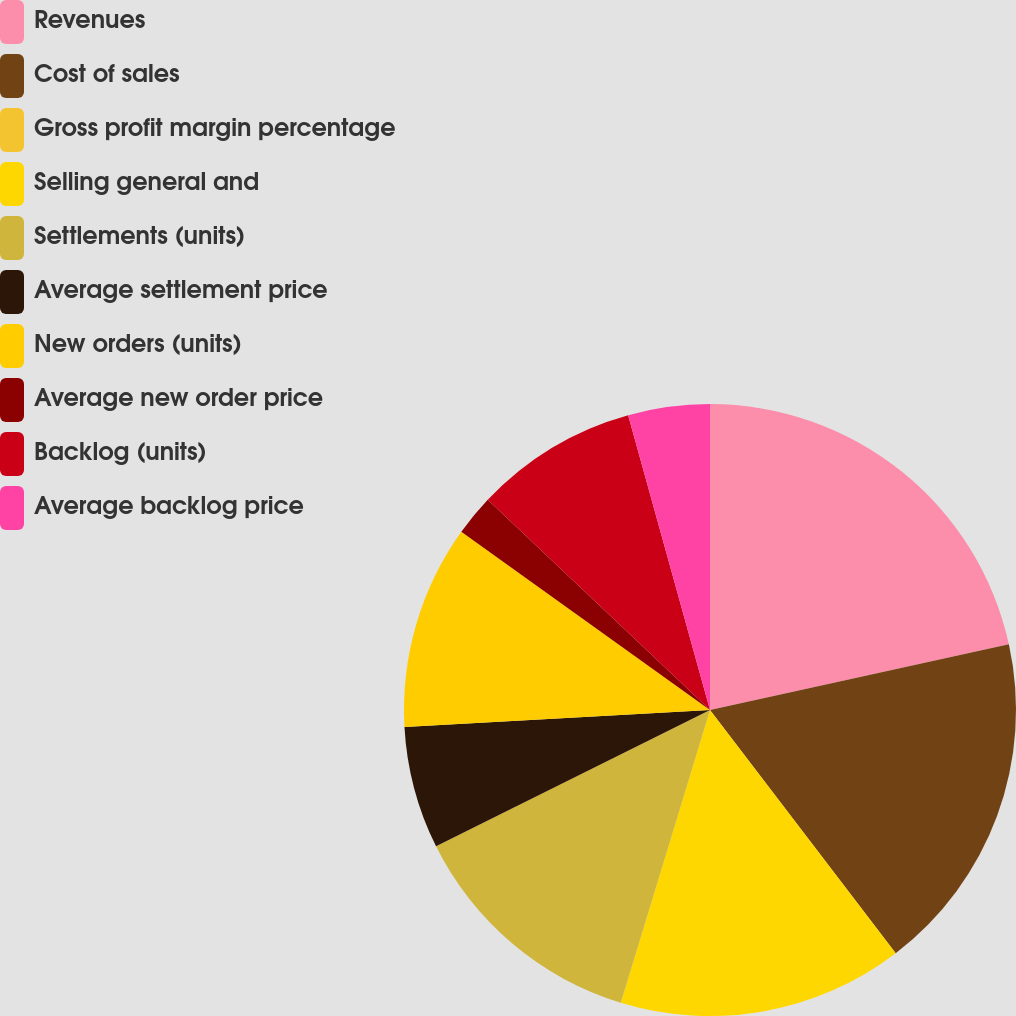Convert chart to OTSL. <chart><loc_0><loc_0><loc_500><loc_500><pie_chart><fcel>Revenues<fcel>Cost of sales<fcel>Gross profit margin percentage<fcel>Selling general and<fcel>Settlements (units)<fcel>Average settlement price<fcel>New orders (units)<fcel>Average new order price<fcel>Backlog (units)<fcel>Average backlog price<nl><fcel>21.56%<fcel>18.06%<fcel>0.0%<fcel>15.09%<fcel>12.94%<fcel>6.47%<fcel>10.78%<fcel>2.16%<fcel>8.63%<fcel>4.31%<nl></chart> 